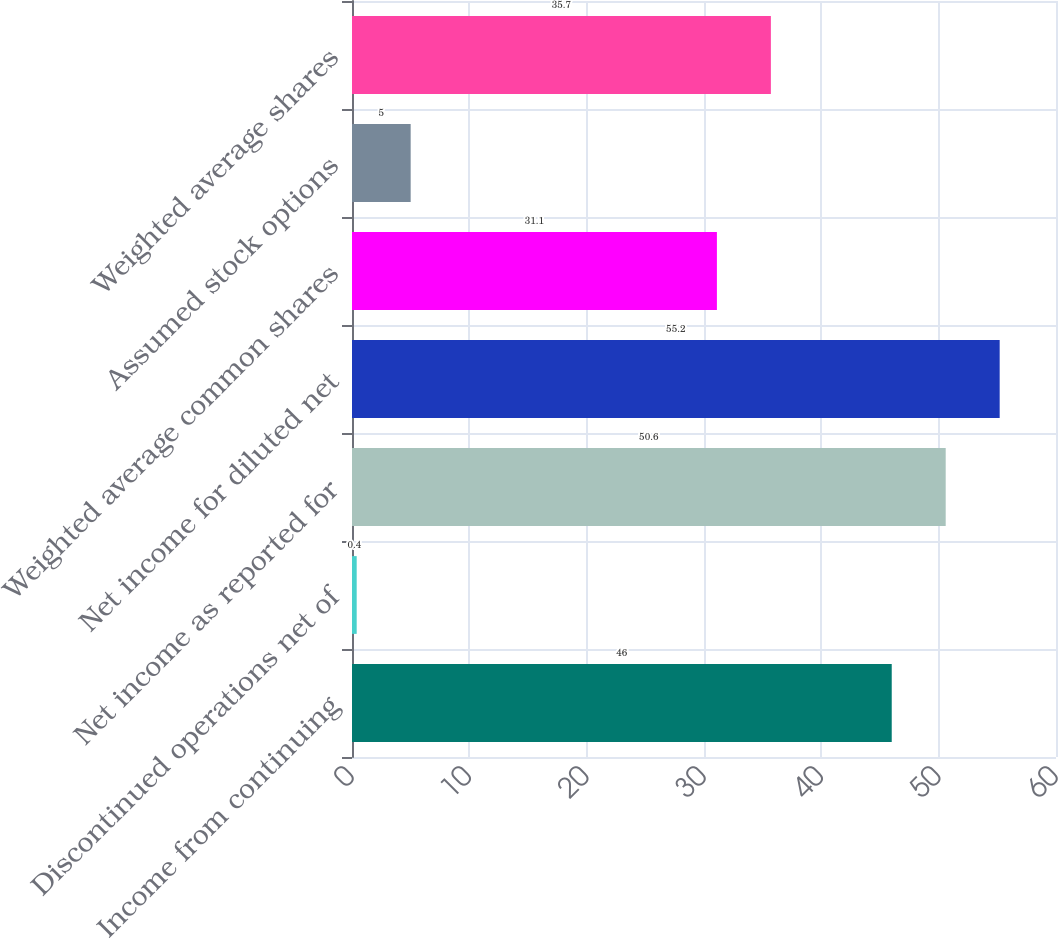Convert chart. <chart><loc_0><loc_0><loc_500><loc_500><bar_chart><fcel>Income from continuing<fcel>Discontinued operations net of<fcel>Net income as reported for<fcel>Net income for diluted net<fcel>Weighted average common shares<fcel>Assumed stock options<fcel>Weighted average shares<nl><fcel>46<fcel>0.4<fcel>50.6<fcel>55.2<fcel>31.1<fcel>5<fcel>35.7<nl></chart> 